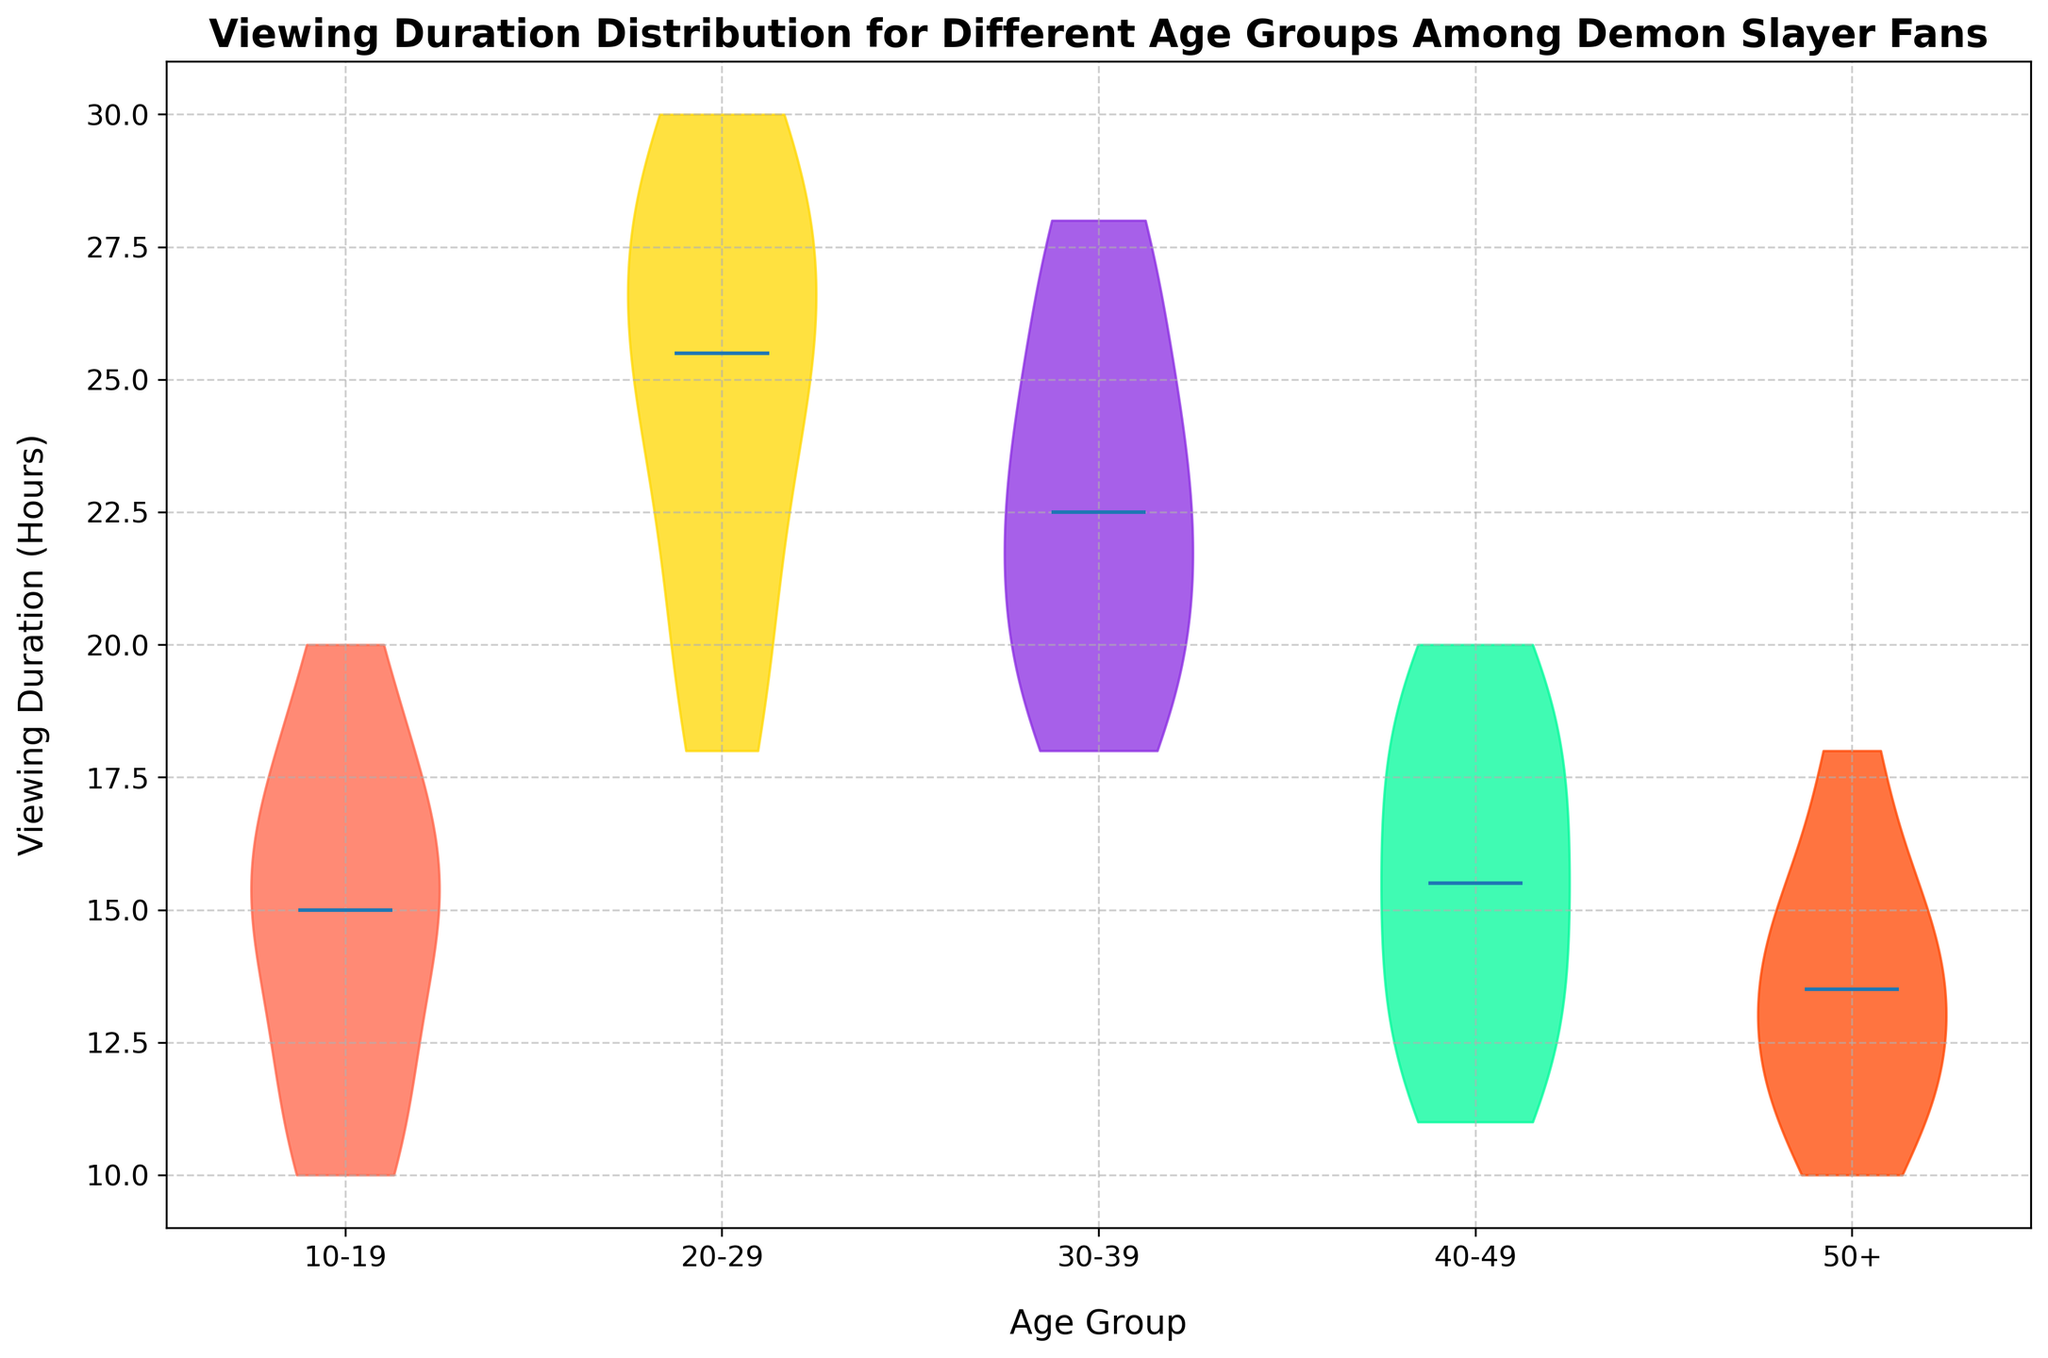What's the median viewing duration for the age group 30-39? The median value is shown in the middle of the violin shape for each group. For the age group 30-39, it's at 23 hours.
Answer: 23 hours Which age group has the widest distribution of viewing duration? The width of the violin plot indicates how spread out the viewing durations are. The 20-29 age group has the widest distribution, indicating a greater variability in viewing durations.
Answer: 20-29 Which age group has the smallest range of viewing durations? The range is the difference between the highest and lowest values. The 50+ age group has durations ranging from 10 to 18 hours, which is the smallest range compared to other groups.
Answer: 50+ Are the viewing durations for the 10-19 age group symmetric? To check symmetry, we look at whether the left and right halves of the violin plot are mirror images. The 10-19 age group has a roughly symmetric distribution.
Answer: Yes What is the approximate peak of the viewing duration for the 40-49 age group? The peak, or the mode, is where the violin plot is the widest. For the 40-49 age group, it appears around 15-18 hours.
Answer: 15-18 hours Compare the central tendency of viewing durations between the 20-29 and 30-39 age groups. The medians are the central tendency indicators, shown as a line through each violin plot. The 20-29 age group's median is at 25 hours, while the 30-39 group's median is at 23 hours.
Answer: 20-29 > 30-39 Is there a noticeable difference between the medians of the 10-19 and 50+ age groups? The median for the 10-19 age group is around 15 hours, whereas for the 50+ age group, it's around 13 hours.
Answer: Yes Which age group has the highest median viewing duration? Medians are indicated by the lines in the violin plots; the 20-29 age group has the highest median at around 25 hours.
Answer: 20-29 What does the concentration of data points in the 50+ age group tell you about its viewing habits? The concentration and narrow range of the 50+ group's violin plot around 10-15 hours indicate most fans in this age group have similar viewing habits, watching for shorter durations.
Answer: Similar, shorter durations 